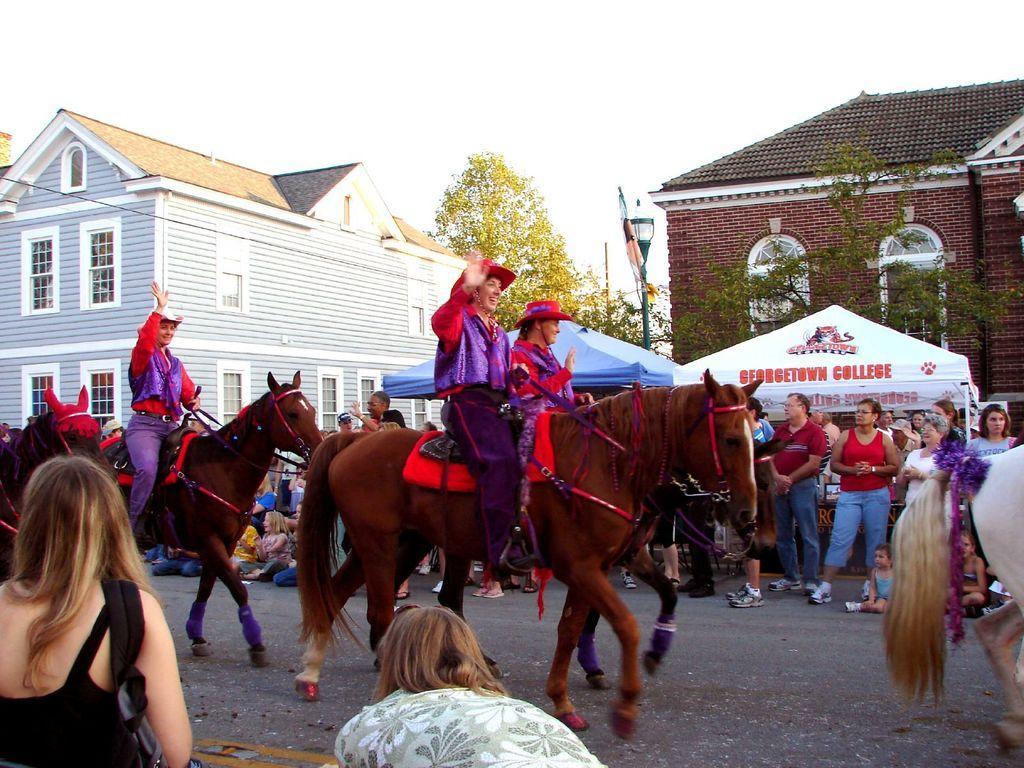Describe this image in one or two sentences. There are 3 women riding horses on the road. On the either side of the road people looking at them. In the background there are buildings,trees and sky. 